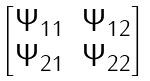Convert formula to latex. <formula><loc_0><loc_0><loc_500><loc_500>\begin{bmatrix} \Psi _ { 1 1 } & \Psi _ { 1 2 } \\ \Psi _ { 2 1 } & \Psi _ { 2 2 } \end{bmatrix}</formula> 